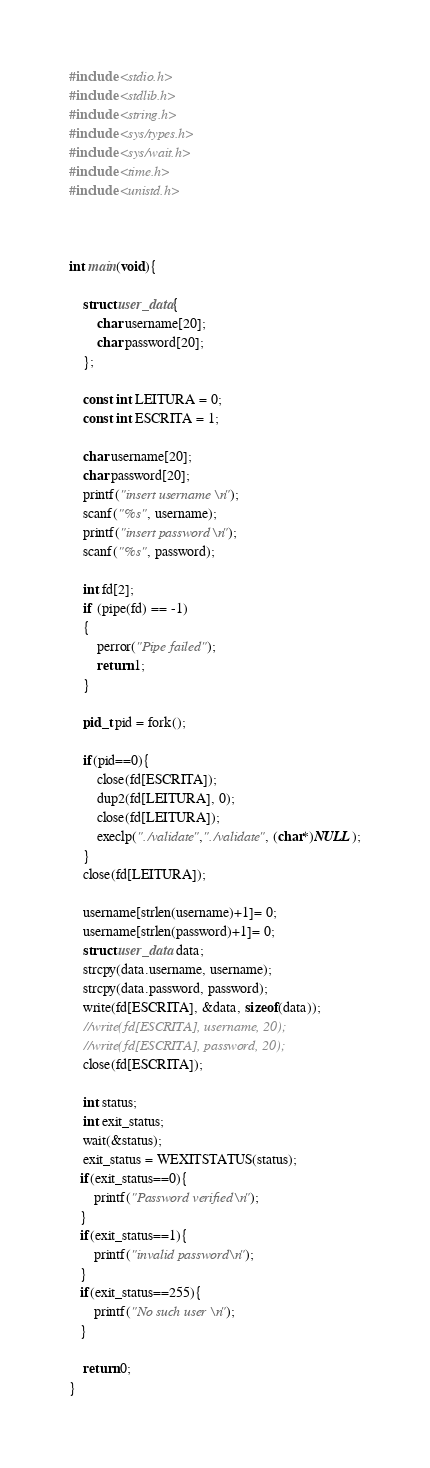<code> <loc_0><loc_0><loc_500><loc_500><_C_>#include <stdio.h>
#include <stdlib.h>
#include <string.h>
#include <sys/types.h>
#include <sys/wait.h>
#include <time.h>
#include <unistd.h>



int main(void){

    struct user_data{
        char username[20];
        char password[20];
    };

    const int LEITURA = 0;
    const int ESCRITA = 1;

    char username[20];
    char password[20];
    printf("insert username\n");
    scanf("%s", username);
    printf("insert password\n");
    scanf("%s", password);
   
    int fd[2];
    if (pipe(fd) == -1)
    {
        perror("Pipe failed");
        return 1;
    }

    pid_t pid = fork();

    if(pid==0){
        close(fd[ESCRITA]);
        dup2(fd[LEITURA], 0);
        close(fd[LEITURA]);
        execlp("./validate","./validate", (char*)NULL);
    }
    close(fd[LEITURA]);
    
    username[strlen(username)+1]= 0;
    username[strlen(password)+1]= 0;
    struct user_data data;
    strcpy(data.username, username);
    strcpy(data.password, password);
    write(fd[ESCRITA], &data, sizeof(data));
    //write(fd[ESCRITA], username, 20);
    //write(fd[ESCRITA], password, 20);
    close(fd[ESCRITA]);

    int status;
    int exit_status;
    wait(&status);
    exit_status = WEXITSTATUS(status);
   if(exit_status==0){
       printf("Password verified\n");
   }
   if(exit_status==1){
       printf("invalid password\n");
   }
   if(exit_status==255){
       printf("No such user\n");
   }

    return 0;
}</code> 